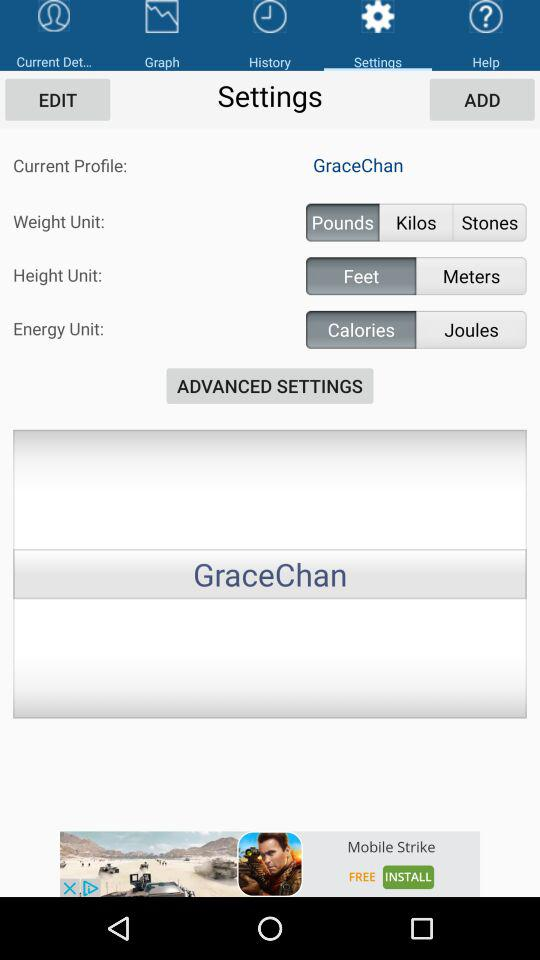What is the unit of height? The unit of height is feet. 